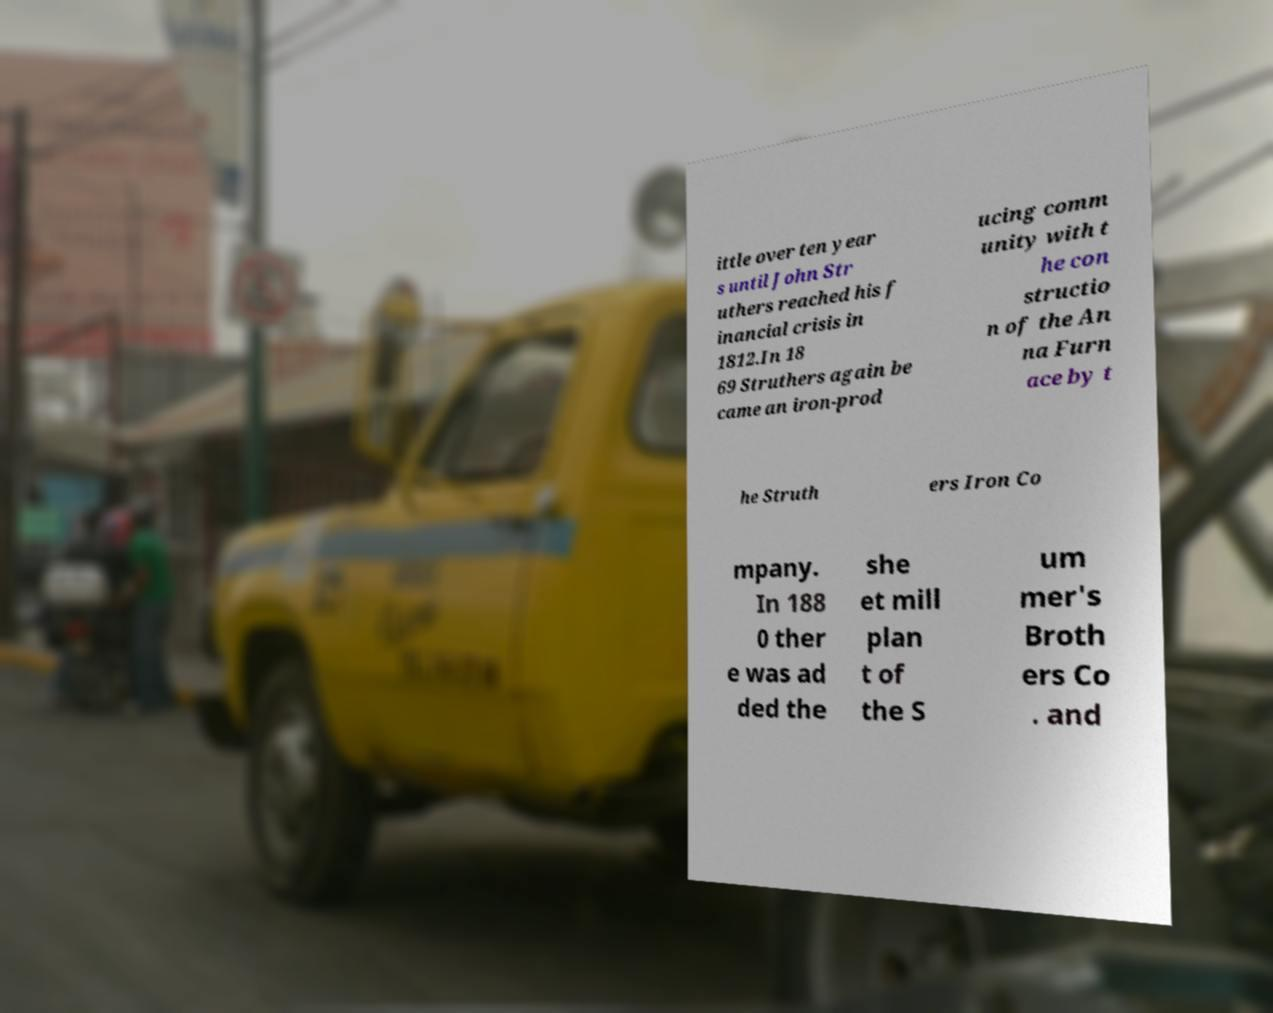Can you accurately transcribe the text from the provided image for me? ittle over ten year s until John Str uthers reached his f inancial crisis in 1812.In 18 69 Struthers again be came an iron-prod ucing comm unity with t he con structio n of the An na Furn ace by t he Struth ers Iron Co mpany. In 188 0 ther e was ad ded the she et mill plan t of the S um mer's Broth ers Co . and 